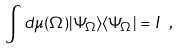Convert formula to latex. <formula><loc_0><loc_0><loc_500><loc_500>\int d \mu ( \Omega ) | \Psi _ { \Omega } \rangle \langle \Psi _ { \Omega } | = I \ ,</formula> 